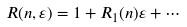<formula> <loc_0><loc_0><loc_500><loc_500>R ( n , \varepsilon ) = 1 + R _ { 1 } ( n ) \varepsilon + \cdots</formula> 